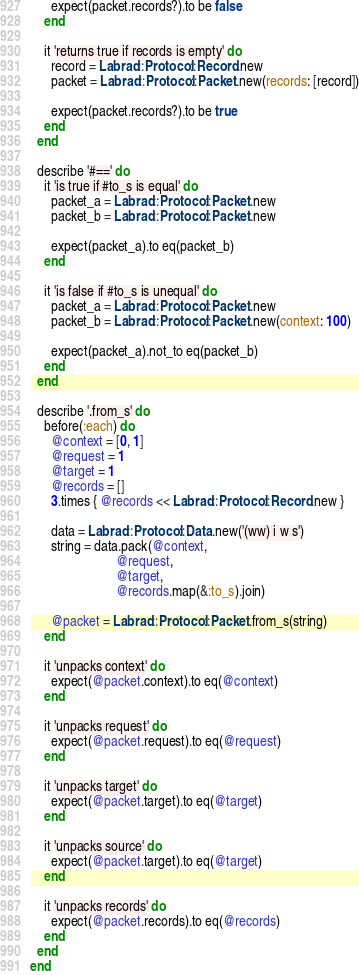Convert code to text. <code><loc_0><loc_0><loc_500><loc_500><_Ruby_>
      expect(packet.records?).to be false
    end

    it 'returns true if records is empty' do
      record = Labrad::Protocol::Record.new
      packet = Labrad::Protocol::Packet.new(records: [record])

      expect(packet.records?).to be true
    end
  end

  describe '#==' do
    it 'is true if #to_s is equal' do
      packet_a = Labrad::Protocol::Packet.new
      packet_b = Labrad::Protocol::Packet.new

      expect(packet_a).to eq(packet_b)
    end

    it 'is false if #to_s is unequal' do
      packet_a = Labrad::Protocol::Packet.new
      packet_b = Labrad::Protocol::Packet.new(context: 100)

      expect(packet_a).not_to eq(packet_b)
    end
  end

  describe '.from_s' do
    before(:each) do
      @context = [0, 1]
      @request = 1
      @target = 1
      @records = []
      3.times { @records << Labrad::Protocol::Record.new }

      data = Labrad::Protocol::Data.new('(ww) i w s')
      string = data.pack(@context,
                         @request,
                         @target,
                         @records.map(&:to_s).join)

      @packet = Labrad::Protocol::Packet.from_s(string)
    end

    it 'unpacks context' do
      expect(@packet.context).to eq(@context)
    end

    it 'unpacks request' do
      expect(@packet.request).to eq(@request)
    end

    it 'unpacks target' do
      expect(@packet.target).to eq(@target)
    end

    it 'unpacks source' do
      expect(@packet.target).to eq(@target)
    end

    it 'unpacks records' do
      expect(@packet.records).to eq(@records)
    end
  end
end
</code> 